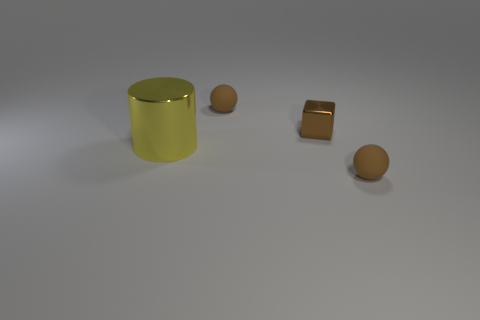Add 4 small things. How many objects exist? 8 Subtract all cylinders. How many objects are left? 3 Subtract 0 purple balls. How many objects are left? 4 Subtract all big cyan objects. Subtract all large cylinders. How many objects are left? 3 Add 2 brown spheres. How many brown spheres are left? 4 Add 2 tiny brown metal blocks. How many tiny brown metal blocks exist? 3 